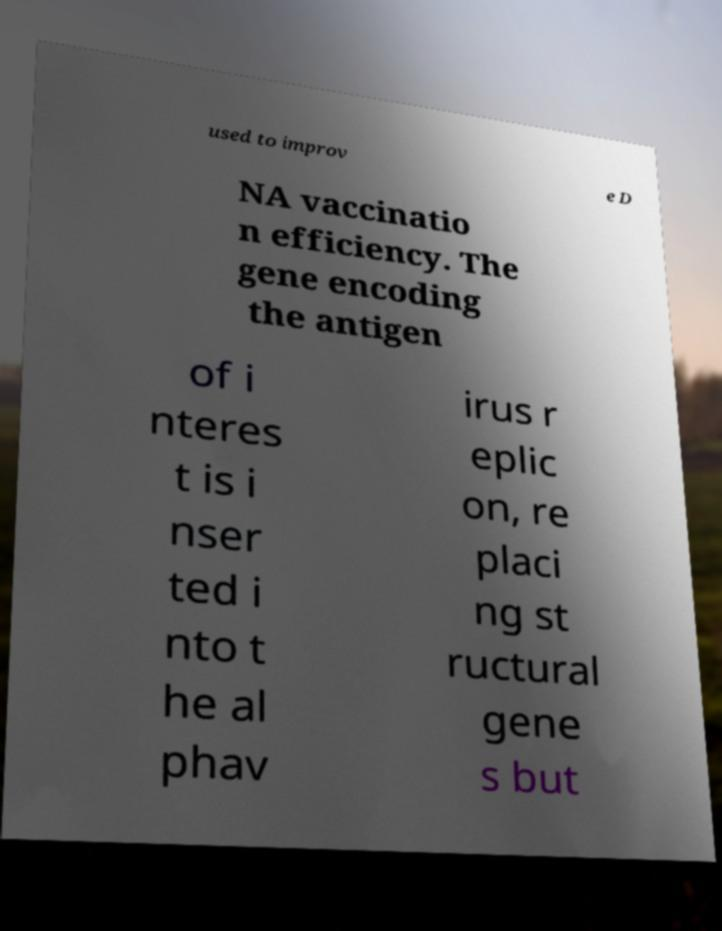Could you assist in decoding the text presented in this image and type it out clearly? used to improv e D NA vaccinatio n efficiency. The gene encoding the antigen of i nteres t is i nser ted i nto t he al phav irus r eplic on, re placi ng st ructural gene s but 